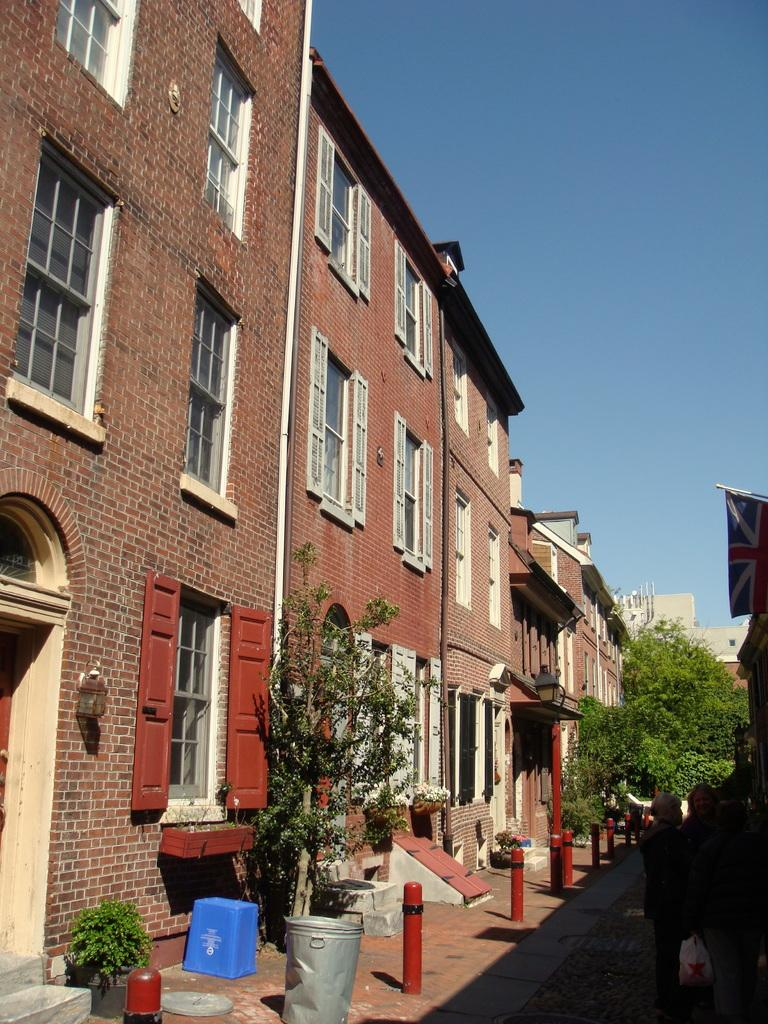What are the people in the image doing? The people in the image are standing on a pavement. What can be seen in the background of the image? In the background of the image, there are iron poles, trees, a building, and the sky. What type of structures are visible in the background? The iron poles and the building are visible in the background. What natural elements can be seen in the background? Trees and the sky are visible in the background. Can you describe the wave pattern on the wall in the image? There is no wave pattern on a wall in the image; the image does not show any walls. 